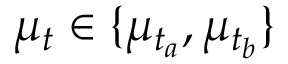Convert formula to latex. <formula><loc_0><loc_0><loc_500><loc_500>\mu _ { t } \in \{ \mu _ { t _ { a } } , \mu _ { t _ { b } } \}</formula> 